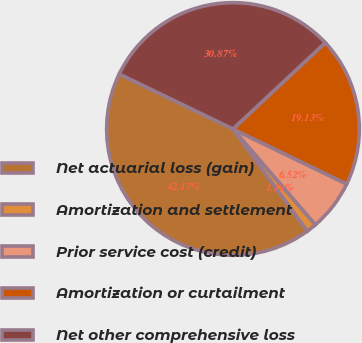Convert chart to OTSL. <chart><loc_0><loc_0><loc_500><loc_500><pie_chart><fcel>Net actuarial loss (gain)<fcel>Amortization and settlement<fcel>Prior service cost (credit)<fcel>Amortization or curtailment<fcel>Net other comprehensive loss<nl><fcel>42.17%<fcel>1.3%<fcel>6.52%<fcel>19.13%<fcel>30.87%<nl></chart> 